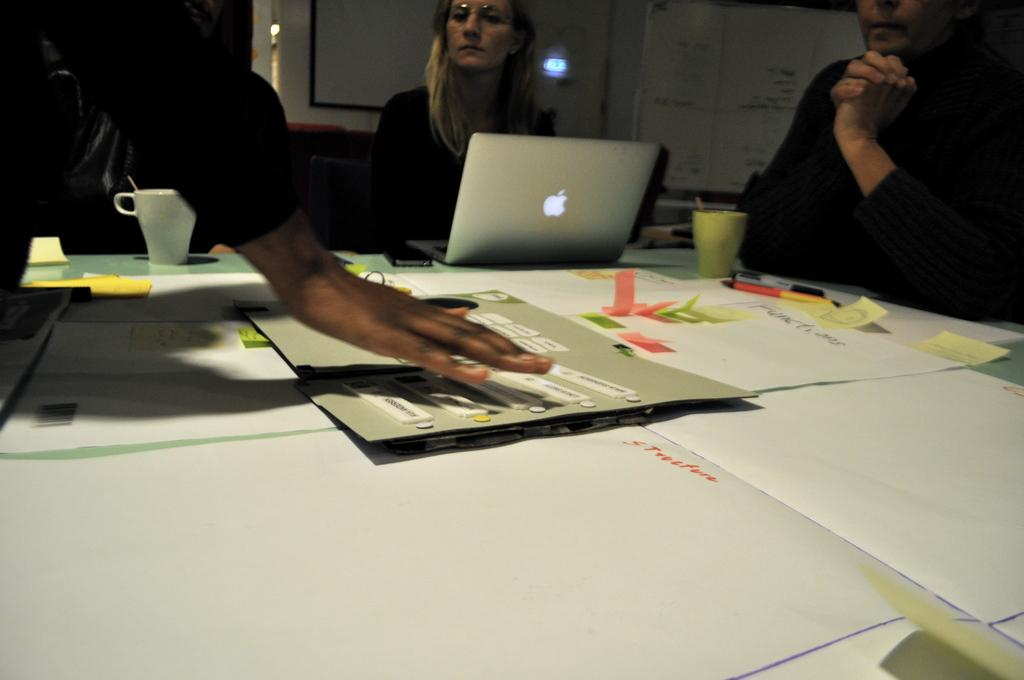What are the people in the image doing? The people are sitting in front of a table. What is on the table in the image? There is a paper, a laptop, and a cup on the table. What can be seen in the background of the image? There is a board in the background. How many snails are crawling on the people's necks in the image? There are no snails present in the image, and therefore no snails are crawling on the people's necks. What color is the bead that is hanging from the laptop in the image? There is no bead hanging from the laptop in the image. 